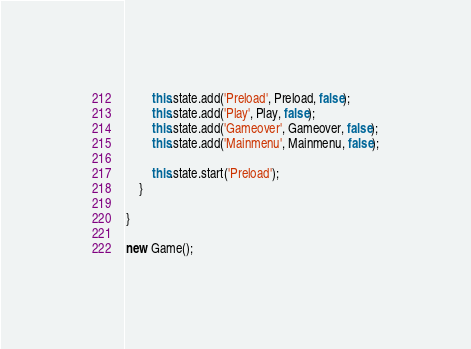Convert code to text. <code><loc_0><loc_0><loc_500><loc_500><_JavaScript_>        this.state.add('Preload', Preload, false);
		this.state.add('Play', Play, false);
        this.state.add('Gameover', Gameover, false);
        this.state.add('Mainmenu', Mainmenu, false);
        
		this.state.start('Preload');
	}

}

new Game();
</code> 